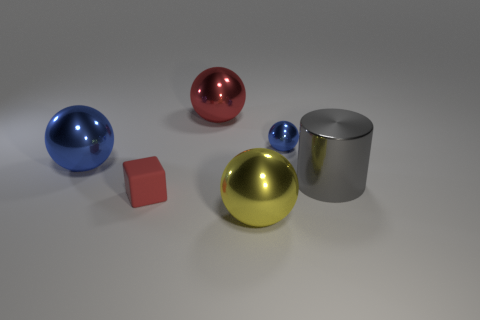Is the number of small matte things that are to the right of the small blue shiny sphere the same as the number of large yellow metal spheres that are in front of the yellow object?
Give a very brief answer. Yes. There is a large metallic thing that is both on the right side of the big red object and on the left side of the metallic cylinder; what is its color?
Make the answer very short. Yellow. Is there any other thing that is the same size as the yellow sphere?
Provide a short and direct response. Yes. Are there more tiny rubber blocks behind the tiny sphere than big metal cylinders in front of the gray metallic cylinder?
Provide a short and direct response. No. Do the blue metallic sphere that is on the left side of the red sphere and the red cube have the same size?
Offer a terse response. No. There is a large metal ball in front of the object that is left of the matte object; what number of red objects are on the right side of it?
Offer a terse response. 0. There is a object that is both in front of the big gray shiny cylinder and behind the yellow object; what size is it?
Make the answer very short. Small. How many other things are the same shape as the tiny blue metallic thing?
Your answer should be very brief. 3. There is a yellow sphere; what number of big gray objects are to the left of it?
Provide a succinct answer. 0. Is the number of large gray metallic objects that are on the left side of the large gray cylinder less than the number of large red balls in front of the red metal object?
Your answer should be compact. No. 